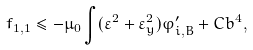<formula> <loc_0><loc_0><loc_500><loc_500>f _ { 1 , 1 } \leq - \mu _ { 0 } \int ( \varepsilon ^ { 2 } + \varepsilon _ { y } ^ { 2 } ) \varphi _ { i , B } ^ { \prime } + C b ^ { 4 } ,</formula> 